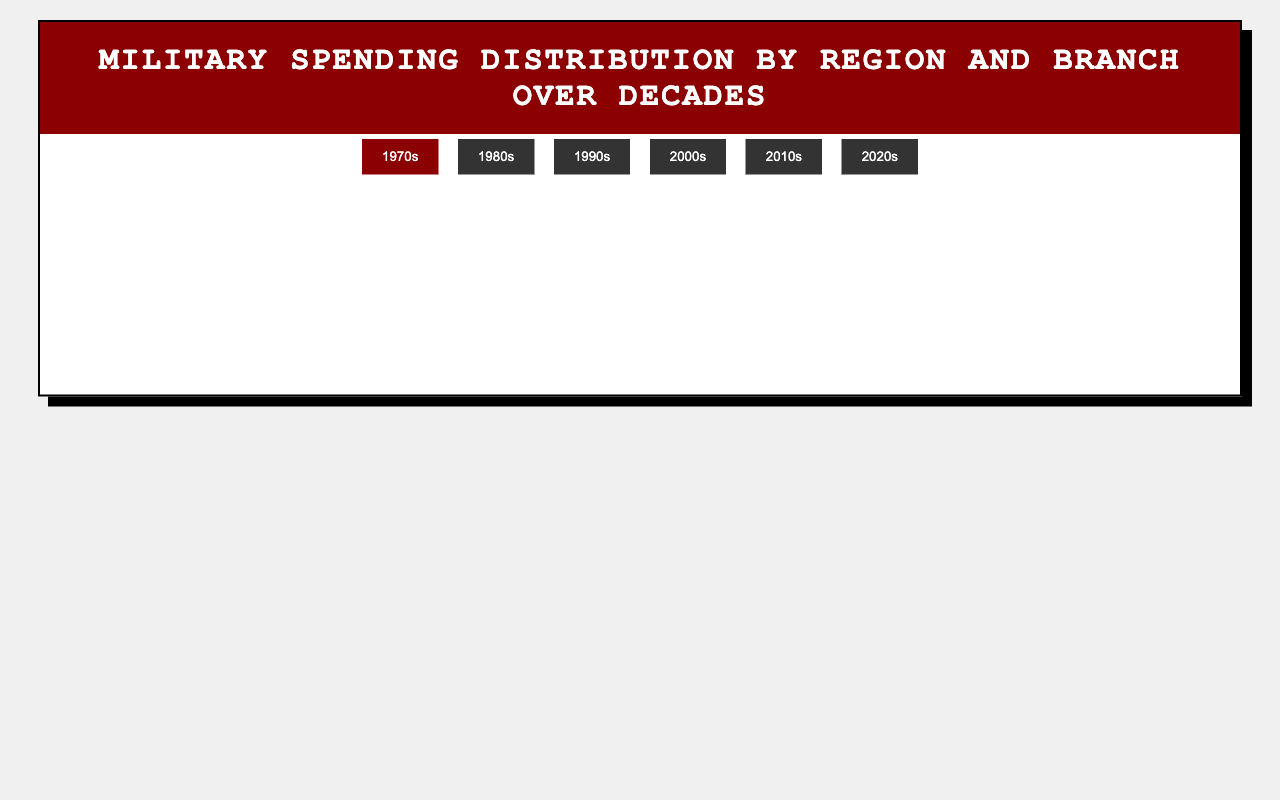Which decade saw the highest proportion of military spending on the Army in North America? First, identify the proportions of Army spending for North America in each decade from the data. '2000s' has the highest value at 45%.
Answer: 2000s Which region had the lowest Navy spending in the 2020s? Look at the Navy spending percentages for all regions in the 2020s. Africa has the lowest at 25%.
Answer: Africa In the 1990s, compare the military spending distribution on the Navy between Asia and the Middle East. Which region spent more? Refer to Navy spending in the 1990s for Asia (20%) and the Middle East (15%). Asia spent 5% more.
Answer: Asia Is the visual height of the Army bar in Africa for the 1970s greater than that of the Air Force bar in North America for the same decade? From the figure, the Army proportion for Africa (1970s) is 80% while the Air Force for North America is 20%. The Army bar is significantly taller.
Answer: Yes Compare the change in Air Force spending between the 1980s and 2020s in South America. Is there an increase or decrease? Check the Air Force percentages for South America in 1980s (20%) and 2020s (30%). There is an increase of 10%.
Answer: Increase Calculate the total percentage spent on Marines across all regions in the 1990s. Add the Marines spending percentages for each region in the 1990s: North America (15%), Europe (10%), Asia (10%), Middle East (10%), Africa (5%), South America (10%). The total is 15+10+10+10+5+10 = 60%.
Answer: 60% Which branch saw an increase in spending in Asia from the 1970s to the 2020s? Identify spending proportions in Asia for each branch in the 1970s and compare them to the 2020s. Only the Navy increased from 15% to 35%.
Answer: Navy Did Europe have a higher proportion of spending on the Army or the Air Force in the 2010s? Compare Europe's spending percentages on Army (30%) and Air Force (25%) in the 2010s. Army has a higher proportion.
Answer: Army Determine the average military spending on the Navy in Africa over the six decades provided. Sum the Navy spending percentages for Africa over all decades: 5% (1970s), 10% (1980s), 10% (1990s), 15% (2000s), 20% (2010s), 25% (2020s) = 85%. The average is 85% over 6 decades = 85/6 ≈ 14.17%.
Answer: 14.17% In the 2000s, how does North America's Air Force spending compare to Europe's? Look at the 2000s data for Air Force spending in North America (25%) and Europe (25%). Both regions spent the same proportion.
Answer: Equal 